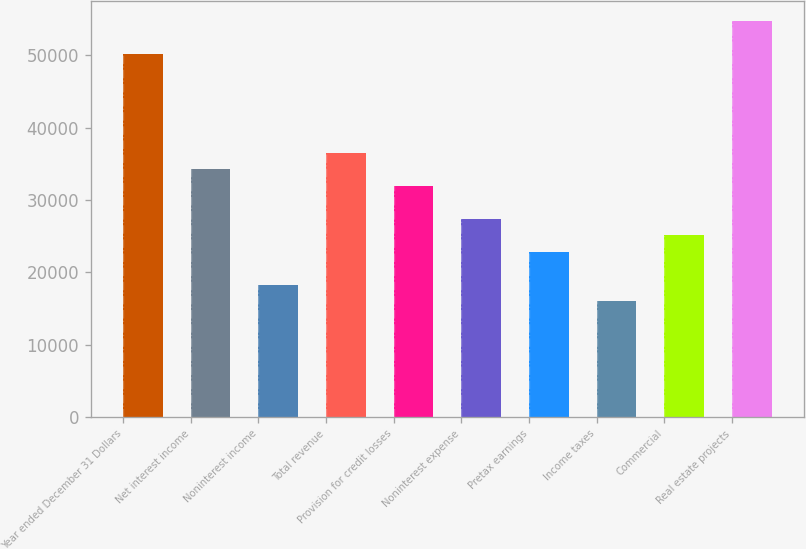Convert chart. <chart><loc_0><loc_0><loc_500><loc_500><bar_chart><fcel>Year ended December 31 Dollars<fcel>Net interest income<fcel>Noninterest income<fcel>Total revenue<fcel>Provision for credit losses<fcel>Noninterest expense<fcel>Pretax earnings<fcel>Income taxes<fcel>Commercial<fcel>Real estate projects<nl><fcel>50255.8<fcel>34265.6<fcel>18275.4<fcel>36549.9<fcel>31981.3<fcel>27412.6<fcel>22844<fcel>15991<fcel>25128.3<fcel>54824.5<nl></chart> 